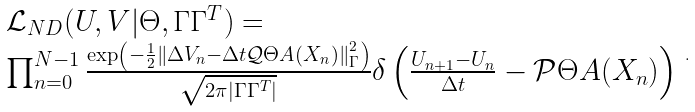<formula> <loc_0><loc_0><loc_500><loc_500>\begin{array} { l } \mathcal { L } _ { N D } ( U , V | \Theta , \Gamma \Gamma ^ { T } ) = \\ \prod _ { n = 0 } ^ { N - 1 } \frac { \exp \left ( - \frac { 1 } { 2 } \left \| \Delta V _ { n } - \Delta t \mathcal { Q } \Theta A ( X _ { n } ) \right \| _ { \Gamma } ^ { 2 } \right ) } { \sqrt { 2 \pi | \Gamma \Gamma ^ { T } | } } \delta \left ( \frac { U _ { n + 1 } - U _ { n } } { \Delta t } - \mathcal { P } \Theta A ( X _ { n } ) \right ) \end{array} .</formula> 